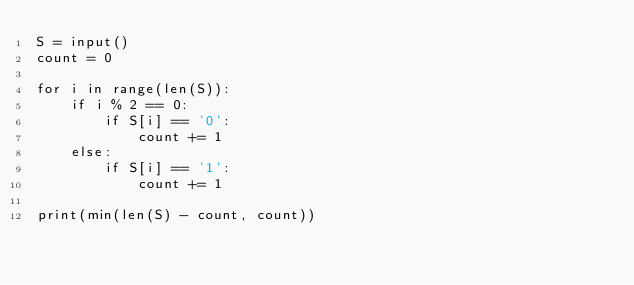Convert code to text. <code><loc_0><loc_0><loc_500><loc_500><_Python_>S = input()
count = 0

for i in range(len(S)):
    if i % 2 == 0:
        if S[i] == '0':
            count += 1
    else:
        if S[i] == '1':
            count += 1

print(min(len(S) - count, count))
</code> 